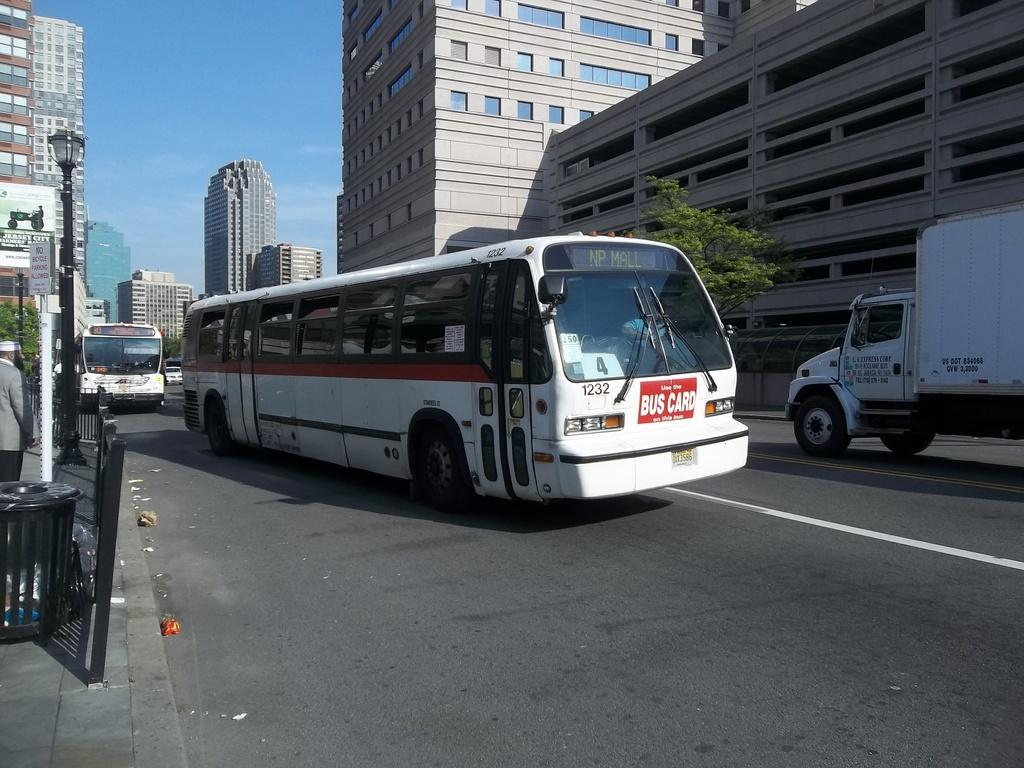What type of vehicle is present in the image? There is a truck in the image. What natural element can be seen in the image? There is a tree in the image. What mode of public transportation is visible in the image? There are white color buses in the image. What type of street fixture is present in the image? There is a street lamp in the image. What type of man-made structures are present in the image? There are buildings in the image. What part of the natural environment is visible in the image? The sky is visible in the image. What type of waste disposal container is present in the image? There is a dustbin in the front of the image. What human presence can be seen in the image? There is a man standing in the front of the image. What type of minister is standing next to the dustbin in the image? There is no minister present in the image; only a man is standing in the front of the image. How many legs does the tree have in the image? Trees do not have legs; they have trunks and branches. 